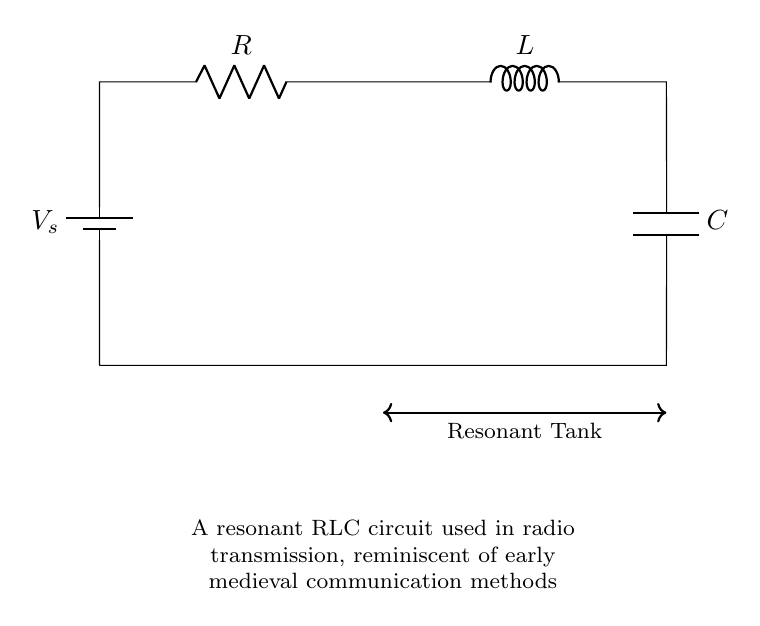What is the voltage source labeled in the circuit? The voltage source in the circuit is labeled as \( V_s \), indicating the potential difference supplied to the circuit components.
Answer: \( V_s \) How many passive components are in the circuit? The circuit contains three passive components: the resistor, inductor, and capacitor. These are the elements that do not supply energy but store or dissipate it.
Answer: 3 What type of circuit is depicted in this diagram? The diagram depicts a resonant RLC circuit, characterized by the specific arrangement of the resistor, inductor, and capacitor designed for resonance, which is essential for radio frequency applications.
Answer: Resonant RLC circuit What is connected in series with the inductor? The resistor \( R \) is connected in series with the inductor \( L \) in the circuit, forming a part of the series loop with all components.
Answer: Resistor Why is resonance significant in this circuit? Resonance is significant because it allows the circuit to oscillate at its natural frequency, maximizing the output voltage at the resonant frequency, which is crucial for effective radio transmission.
Answer: Maximizes output voltage What is the role of the capacitor in this RLC circuit? The capacitor stores and releases electrical energy, working in conjunction with the inductor to create oscillations that are vital for tuning the circuit to specific frequencies in radio transmission.
Answer: Stores electrical energy What does the thick arrow labeled "Resonant Tank" indicate? The thick arrow labeled "Resonant Tank" indicates the portion of the circuit responsible for the resonant behavior, revealing the coupling between the inductor and capacitor that enables the circuit to resonate.
Answer: Resonant behavior indicator 